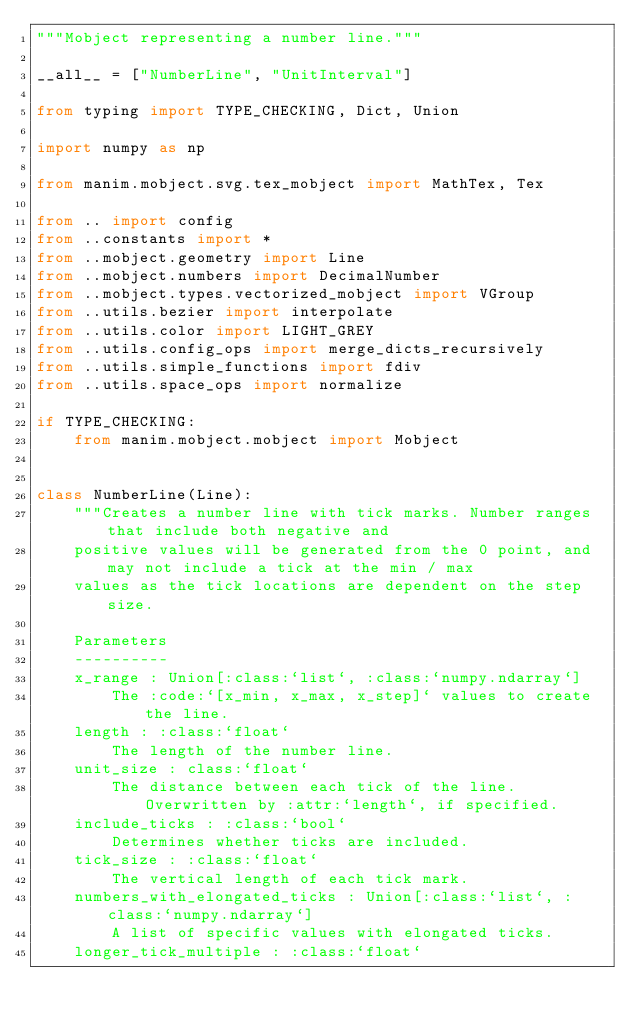Convert code to text. <code><loc_0><loc_0><loc_500><loc_500><_Python_>"""Mobject representing a number line."""

__all__ = ["NumberLine", "UnitInterval"]

from typing import TYPE_CHECKING, Dict, Union

import numpy as np

from manim.mobject.svg.tex_mobject import MathTex, Tex

from .. import config
from ..constants import *
from ..mobject.geometry import Line
from ..mobject.numbers import DecimalNumber
from ..mobject.types.vectorized_mobject import VGroup
from ..utils.bezier import interpolate
from ..utils.color import LIGHT_GREY
from ..utils.config_ops import merge_dicts_recursively
from ..utils.simple_functions import fdiv
from ..utils.space_ops import normalize

if TYPE_CHECKING:
    from manim.mobject.mobject import Mobject


class NumberLine(Line):
    """Creates a number line with tick marks. Number ranges that include both negative and
    positive values will be generated from the 0 point, and may not include a tick at the min / max
    values as the tick locations are dependent on the step size.

    Parameters
    ----------
    x_range : Union[:class:`list`, :class:`numpy.ndarray`]
        The :code:`[x_min, x_max, x_step]` values to create the line.
    length : :class:`float`
        The length of the number line.
    unit_size : class:`float`
        The distance between each tick of the line. Overwritten by :attr:`length`, if specified.
    include_ticks : :class:`bool`
        Determines whether ticks are included.
    tick_size : :class:`float`
        The vertical length of each tick mark.
    numbers_with_elongated_ticks : Union[:class:`list`, :class:`numpy.ndarray`]
        A list of specific values with elongated ticks.
    longer_tick_multiple : :class:`float`</code> 